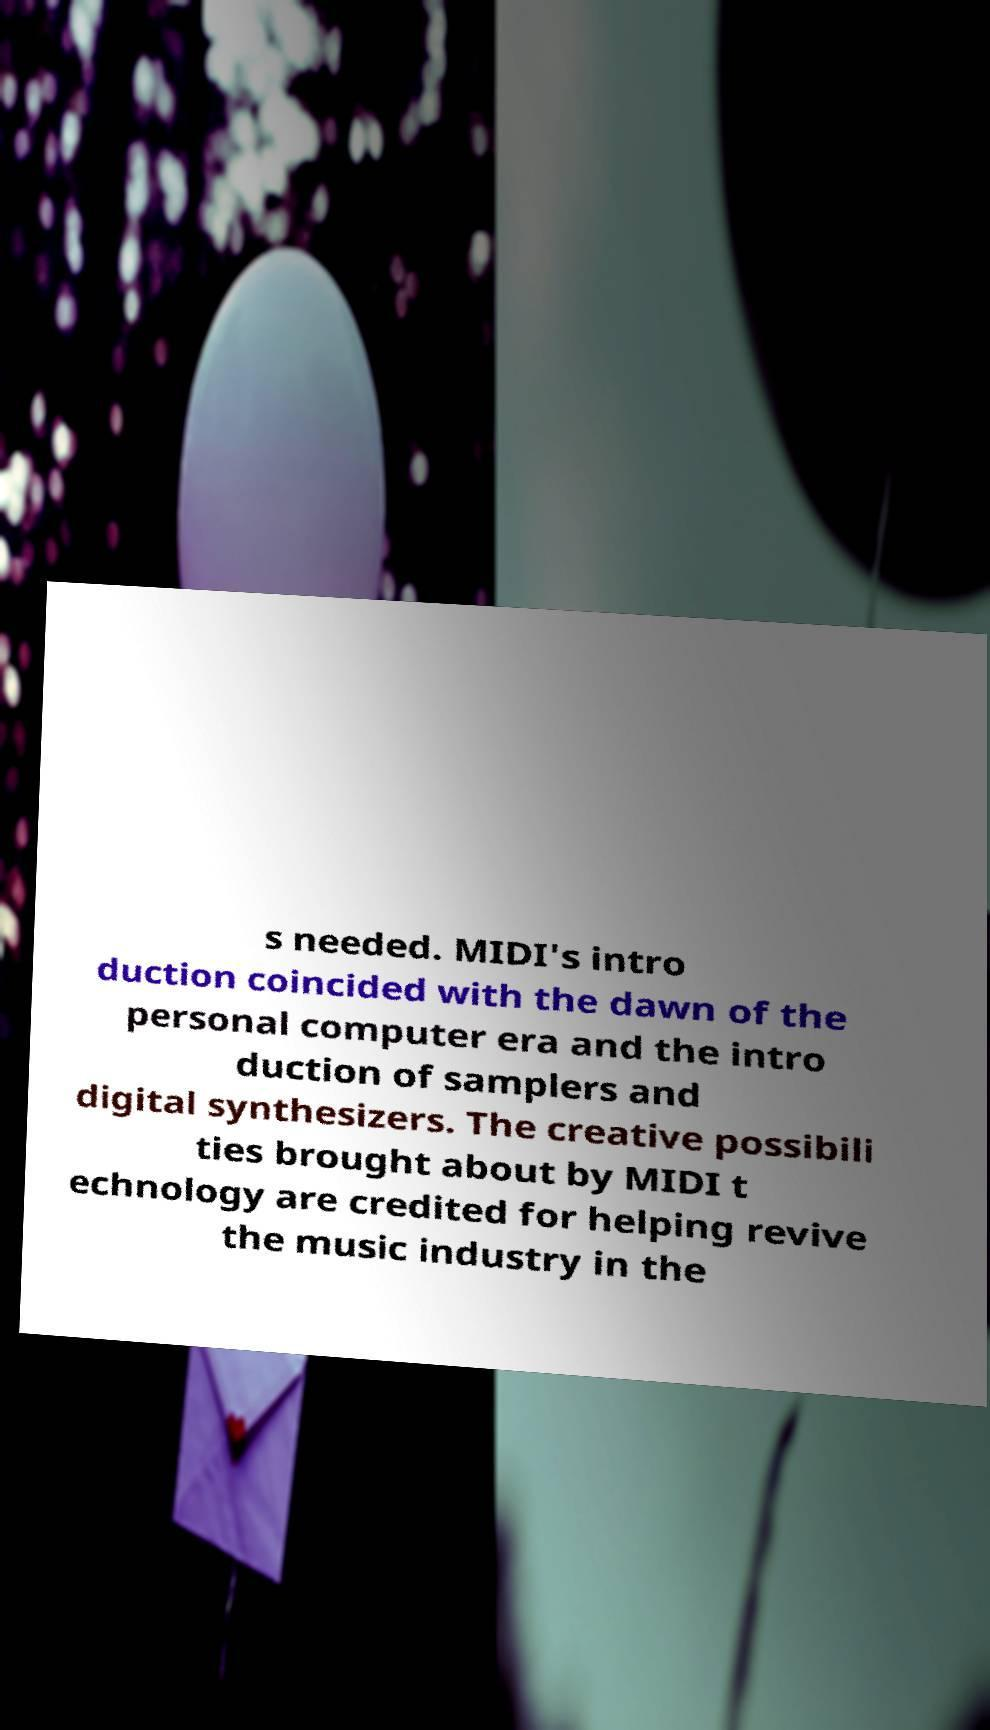Could you assist in decoding the text presented in this image and type it out clearly? s needed. MIDI's intro duction coincided with the dawn of the personal computer era and the intro duction of samplers and digital synthesizers. The creative possibili ties brought about by MIDI t echnology are credited for helping revive the music industry in the 